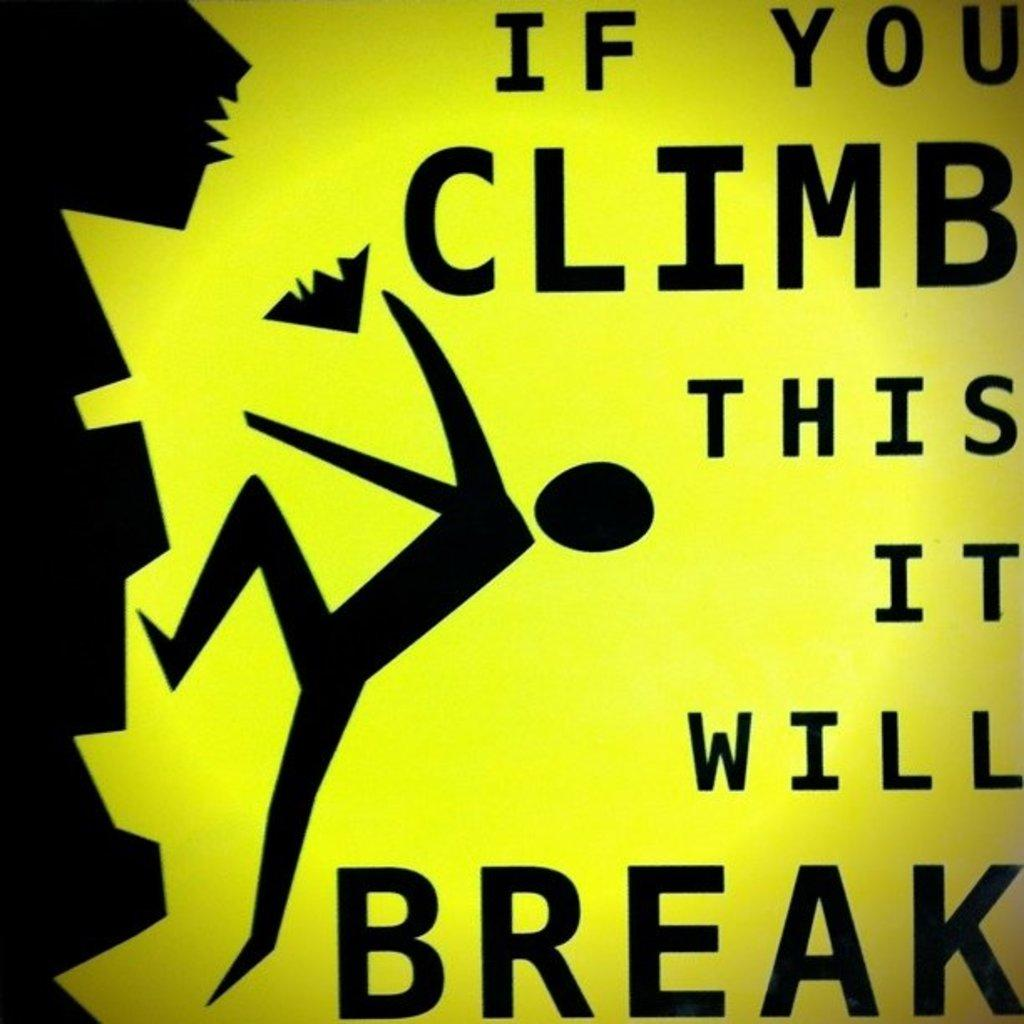<image>
Present a compact description of the photo's key features. A sign that says "If you climb this it will break." 